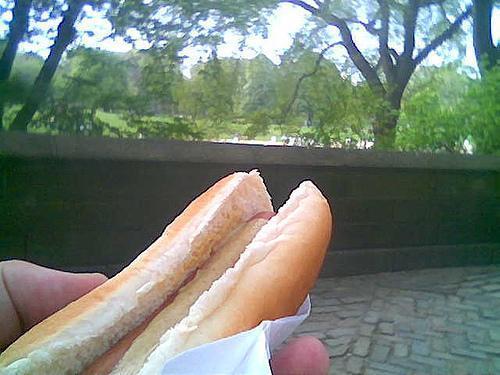How many black cats are in the picture?
Give a very brief answer. 0. 